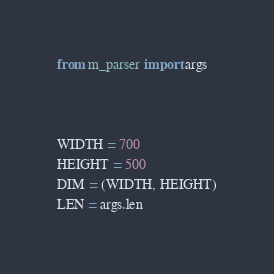Convert code to text. <code><loc_0><loc_0><loc_500><loc_500><_Python_>from m_parser import args



WIDTH = 700
HEIGHT = 500
DIM = (WIDTH, HEIGHT)
LEN = args.len
</code> 